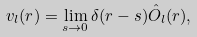Convert formula to latex. <formula><loc_0><loc_0><loc_500><loc_500>v _ { l } ( r ) = \lim _ { s \to 0 } \delta ( r - s ) \hat { O } _ { l } ( r ) ,</formula> 